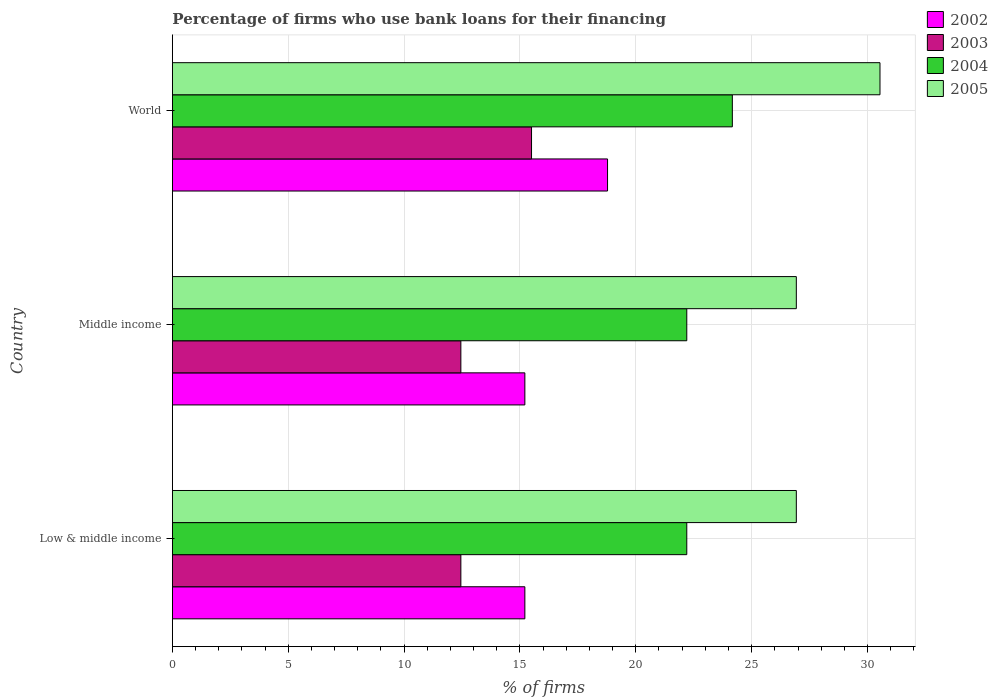Are the number of bars on each tick of the Y-axis equal?
Your response must be concise. Yes. What is the label of the 2nd group of bars from the top?
Ensure brevity in your answer.  Middle income. What is the percentage of firms who use bank loans for their financing in 2004 in Middle income?
Ensure brevity in your answer.  22.2. Across all countries, what is the maximum percentage of firms who use bank loans for their financing in 2002?
Offer a very short reply. 18.78. Across all countries, what is the minimum percentage of firms who use bank loans for their financing in 2003?
Provide a short and direct response. 12.45. What is the total percentage of firms who use bank loans for their financing in 2003 in the graph?
Provide a succinct answer. 40.4. What is the difference between the percentage of firms who use bank loans for their financing in 2005 in Middle income and the percentage of firms who use bank loans for their financing in 2004 in Low & middle income?
Keep it short and to the point. 4.73. What is the average percentage of firms who use bank loans for their financing in 2005 per country?
Give a very brief answer. 28.13. What is the difference between the percentage of firms who use bank loans for their financing in 2005 and percentage of firms who use bank loans for their financing in 2003 in World?
Keep it short and to the point. 15.04. What is the ratio of the percentage of firms who use bank loans for their financing in 2004 in Low & middle income to that in World?
Offer a terse response. 0.92. Is the percentage of firms who use bank loans for their financing in 2005 in Middle income less than that in World?
Your response must be concise. Yes. Is the difference between the percentage of firms who use bank loans for their financing in 2005 in Low & middle income and Middle income greater than the difference between the percentage of firms who use bank loans for their financing in 2003 in Low & middle income and Middle income?
Keep it short and to the point. No. What is the difference between the highest and the second highest percentage of firms who use bank loans for their financing in 2003?
Give a very brief answer. 3.05. What is the difference between the highest and the lowest percentage of firms who use bank loans for their financing in 2005?
Your response must be concise. 3.61. Is the sum of the percentage of firms who use bank loans for their financing in 2003 in Middle income and World greater than the maximum percentage of firms who use bank loans for their financing in 2002 across all countries?
Your response must be concise. Yes. What does the 1st bar from the top in World represents?
Your answer should be compact. 2005. Is it the case that in every country, the sum of the percentage of firms who use bank loans for their financing in 2005 and percentage of firms who use bank loans for their financing in 2004 is greater than the percentage of firms who use bank loans for their financing in 2003?
Make the answer very short. Yes. Does the graph contain any zero values?
Your answer should be very brief. No. Does the graph contain grids?
Give a very brief answer. Yes. How many legend labels are there?
Provide a succinct answer. 4. What is the title of the graph?
Keep it short and to the point. Percentage of firms who use bank loans for their financing. Does "1960" appear as one of the legend labels in the graph?
Provide a short and direct response. No. What is the label or title of the X-axis?
Your answer should be very brief. % of firms. What is the % of firms in 2002 in Low & middle income?
Offer a terse response. 15.21. What is the % of firms in 2003 in Low & middle income?
Your answer should be compact. 12.45. What is the % of firms of 2005 in Low & middle income?
Your response must be concise. 26.93. What is the % of firms of 2002 in Middle income?
Provide a short and direct response. 15.21. What is the % of firms of 2003 in Middle income?
Ensure brevity in your answer.  12.45. What is the % of firms in 2005 in Middle income?
Offer a very short reply. 26.93. What is the % of firms of 2002 in World?
Your answer should be very brief. 18.78. What is the % of firms in 2004 in World?
Ensure brevity in your answer.  24.17. What is the % of firms of 2005 in World?
Your answer should be compact. 30.54. Across all countries, what is the maximum % of firms in 2002?
Your answer should be compact. 18.78. Across all countries, what is the maximum % of firms in 2003?
Offer a terse response. 15.5. Across all countries, what is the maximum % of firms of 2004?
Provide a succinct answer. 24.17. Across all countries, what is the maximum % of firms in 2005?
Offer a very short reply. 30.54. Across all countries, what is the minimum % of firms of 2002?
Ensure brevity in your answer.  15.21. Across all countries, what is the minimum % of firms of 2003?
Ensure brevity in your answer.  12.45. Across all countries, what is the minimum % of firms in 2005?
Offer a terse response. 26.93. What is the total % of firms of 2002 in the graph?
Your response must be concise. 49.21. What is the total % of firms of 2003 in the graph?
Your answer should be very brief. 40.4. What is the total % of firms of 2004 in the graph?
Your response must be concise. 68.57. What is the total % of firms of 2005 in the graph?
Your answer should be very brief. 84.39. What is the difference between the % of firms of 2002 in Low & middle income and that in Middle income?
Offer a very short reply. 0. What is the difference between the % of firms in 2003 in Low & middle income and that in Middle income?
Give a very brief answer. 0. What is the difference between the % of firms in 2005 in Low & middle income and that in Middle income?
Make the answer very short. 0. What is the difference between the % of firms in 2002 in Low & middle income and that in World?
Give a very brief answer. -3.57. What is the difference between the % of firms in 2003 in Low & middle income and that in World?
Your answer should be compact. -3.05. What is the difference between the % of firms in 2004 in Low & middle income and that in World?
Your answer should be very brief. -1.97. What is the difference between the % of firms of 2005 in Low & middle income and that in World?
Offer a very short reply. -3.61. What is the difference between the % of firms in 2002 in Middle income and that in World?
Provide a succinct answer. -3.57. What is the difference between the % of firms of 2003 in Middle income and that in World?
Offer a terse response. -3.05. What is the difference between the % of firms of 2004 in Middle income and that in World?
Ensure brevity in your answer.  -1.97. What is the difference between the % of firms in 2005 in Middle income and that in World?
Give a very brief answer. -3.61. What is the difference between the % of firms in 2002 in Low & middle income and the % of firms in 2003 in Middle income?
Keep it short and to the point. 2.76. What is the difference between the % of firms in 2002 in Low & middle income and the % of firms in 2004 in Middle income?
Make the answer very short. -6.99. What is the difference between the % of firms in 2002 in Low & middle income and the % of firms in 2005 in Middle income?
Make the answer very short. -11.72. What is the difference between the % of firms of 2003 in Low & middle income and the % of firms of 2004 in Middle income?
Provide a short and direct response. -9.75. What is the difference between the % of firms of 2003 in Low & middle income and the % of firms of 2005 in Middle income?
Give a very brief answer. -14.48. What is the difference between the % of firms in 2004 in Low & middle income and the % of firms in 2005 in Middle income?
Provide a short and direct response. -4.73. What is the difference between the % of firms of 2002 in Low & middle income and the % of firms of 2003 in World?
Your answer should be compact. -0.29. What is the difference between the % of firms of 2002 in Low & middle income and the % of firms of 2004 in World?
Ensure brevity in your answer.  -8.95. What is the difference between the % of firms of 2002 in Low & middle income and the % of firms of 2005 in World?
Provide a short and direct response. -15.33. What is the difference between the % of firms in 2003 in Low & middle income and the % of firms in 2004 in World?
Provide a short and direct response. -11.72. What is the difference between the % of firms of 2003 in Low & middle income and the % of firms of 2005 in World?
Your response must be concise. -18.09. What is the difference between the % of firms of 2004 in Low & middle income and the % of firms of 2005 in World?
Provide a short and direct response. -8.34. What is the difference between the % of firms of 2002 in Middle income and the % of firms of 2003 in World?
Your answer should be very brief. -0.29. What is the difference between the % of firms of 2002 in Middle income and the % of firms of 2004 in World?
Give a very brief answer. -8.95. What is the difference between the % of firms of 2002 in Middle income and the % of firms of 2005 in World?
Provide a short and direct response. -15.33. What is the difference between the % of firms in 2003 in Middle income and the % of firms in 2004 in World?
Offer a very short reply. -11.72. What is the difference between the % of firms of 2003 in Middle income and the % of firms of 2005 in World?
Provide a short and direct response. -18.09. What is the difference between the % of firms in 2004 in Middle income and the % of firms in 2005 in World?
Make the answer very short. -8.34. What is the average % of firms of 2002 per country?
Give a very brief answer. 16.4. What is the average % of firms in 2003 per country?
Your response must be concise. 13.47. What is the average % of firms of 2004 per country?
Your answer should be compact. 22.86. What is the average % of firms in 2005 per country?
Offer a very short reply. 28.13. What is the difference between the % of firms in 2002 and % of firms in 2003 in Low & middle income?
Provide a succinct answer. 2.76. What is the difference between the % of firms of 2002 and % of firms of 2004 in Low & middle income?
Give a very brief answer. -6.99. What is the difference between the % of firms in 2002 and % of firms in 2005 in Low & middle income?
Keep it short and to the point. -11.72. What is the difference between the % of firms in 2003 and % of firms in 2004 in Low & middle income?
Ensure brevity in your answer.  -9.75. What is the difference between the % of firms in 2003 and % of firms in 2005 in Low & middle income?
Ensure brevity in your answer.  -14.48. What is the difference between the % of firms of 2004 and % of firms of 2005 in Low & middle income?
Give a very brief answer. -4.73. What is the difference between the % of firms of 2002 and % of firms of 2003 in Middle income?
Offer a terse response. 2.76. What is the difference between the % of firms of 2002 and % of firms of 2004 in Middle income?
Your response must be concise. -6.99. What is the difference between the % of firms in 2002 and % of firms in 2005 in Middle income?
Your response must be concise. -11.72. What is the difference between the % of firms in 2003 and % of firms in 2004 in Middle income?
Give a very brief answer. -9.75. What is the difference between the % of firms of 2003 and % of firms of 2005 in Middle income?
Your answer should be very brief. -14.48. What is the difference between the % of firms of 2004 and % of firms of 2005 in Middle income?
Ensure brevity in your answer.  -4.73. What is the difference between the % of firms of 2002 and % of firms of 2003 in World?
Your response must be concise. 3.28. What is the difference between the % of firms in 2002 and % of firms in 2004 in World?
Ensure brevity in your answer.  -5.39. What is the difference between the % of firms of 2002 and % of firms of 2005 in World?
Keep it short and to the point. -11.76. What is the difference between the % of firms in 2003 and % of firms in 2004 in World?
Offer a terse response. -8.67. What is the difference between the % of firms in 2003 and % of firms in 2005 in World?
Provide a succinct answer. -15.04. What is the difference between the % of firms of 2004 and % of firms of 2005 in World?
Your response must be concise. -6.37. What is the ratio of the % of firms in 2002 in Low & middle income to that in Middle income?
Provide a succinct answer. 1. What is the ratio of the % of firms of 2004 in Low & middle income to that in Middle income?
Provide a succinct answer. 1. What is the ratio of the % of firms of 2002 in Low & middle income to that in World?
Your response must be concise. 0.81. What is the ratio of the % of firms of 2003 in Low & middle income to that in World?
Your response must be concise. 0.8. What is the ratio of the % of firms of 2004 in Low & middle income to that in World?
Your response must be concise. 0.92. What is the ratio of the % of firms of 2005 in Low & middle income to that in World?
Provide a short and direct response. 0.88. What is the ratio of the % of firms in 2002 in Middle income to that in World?
Your response must be concise. 0.81. What is the ratio of the % of firms in 2003 in Middle income to that in World?
Provide a succinct answer. 0.8. What is the ratio of the % of firms of 2004 in Middle income to that in World?
Ensure brevity in your answer.  0.92. What is the ratio of the % of firms of 2005 in Middle income to that in World?
Give a very brief answer. 0.88. What is the difference between the highest and the second highest % of firms in 2002?
Ensure brevity in your answer.  3.57. What is the difference between the highest and the second highest % of firms in 2003?
Offer a very short reply. 3.05. What is the difference between the highest and the second highest % of firms of 2004?
Provide a succinct answer. 1.97. What is the difference between the highest and the second highest % of firms in 2005?
Your answer should be compact. 3.61. What is the difference between the highest and the lowest % of firms of 2002?
Offer a very short reply. 3.57. What is the difference between the highest and the lowest % of firms in 2003?
Offer a terse response. 3.05. What is the difference between the highest and the lowest % of firms in 2004?
Keep it short and to the point. 1.97. What is the difference between the highest and the lowest % of firms in 2005?
Provide a short and direct response. 3.61. 